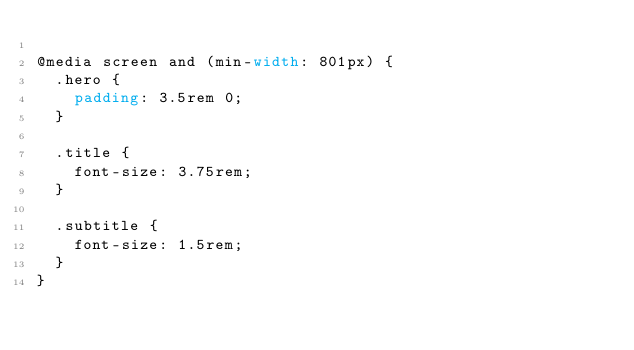<code> <loc_0><loc_0><loc_500><loc_500><_CSS_>
@media screen and (min-width: 801px) {
  .hero {
    padding: 3.5rem 0;
  }

  .title {
    font-size: 3.75rem;
  }

  .subtitle {
    font-size: 1.5rem;
  }
}
</code> 